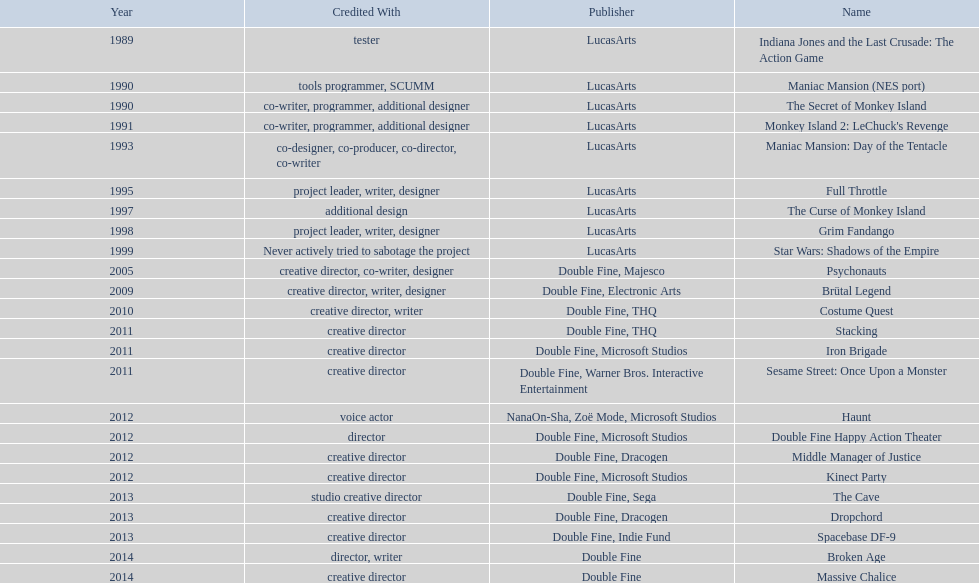What game name has tim schafer been involved with? Indiana Jones and the Last Crusade: The Action Game, Maniac Mansion (NES port), The Secret of Monkey Island, Monkey Island 2: LeChuck's Revenge, Maniac Mansion: Day of the Tentacle, Full Throttle, The Curse of Monkey Island, Grim Fandango, Star Wars: Shadows of the Empire, Psychonauts, Brütal Legend, Costume Quest, Stacking, Iron Brigade, Sesame Street: Once Upon a Monster, Haunt, Double Fine Happy Action Theater, Middle Manager of Justice, Kinect Party, The Cave, Dropchord, Spacebase DF-9, Broken Age, Massive Chalice. Which game has credit with just creative director? Creative director, creative director, creative director, creative director, creative director, creative director, creative director, creative director. Which games have the above and warner bros. interactive entertainment as publisher? Sesame Street: Once Upon a Monster. 